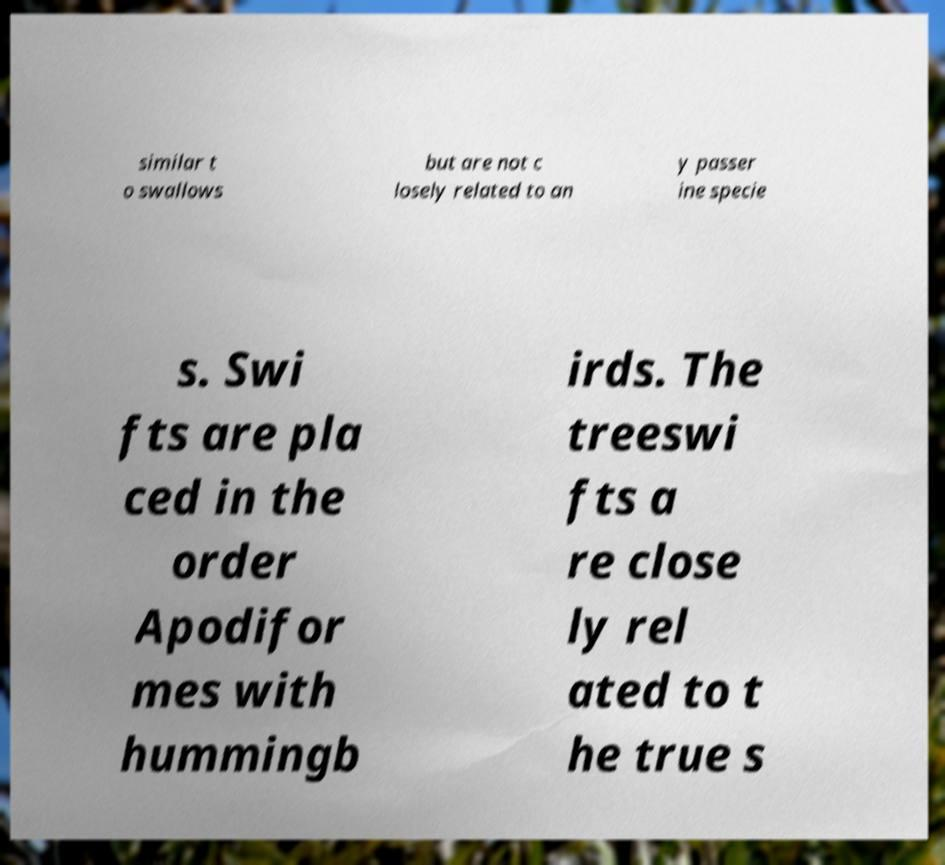Please identify and transcribe the text found in this image. similar t o swallows but are not c losely related to an y passer ine specie s. Swi fts are pla ced in the order Apodifor mes with hummingb irds. The treeswi fts a re close ly rel ated to t he true s 